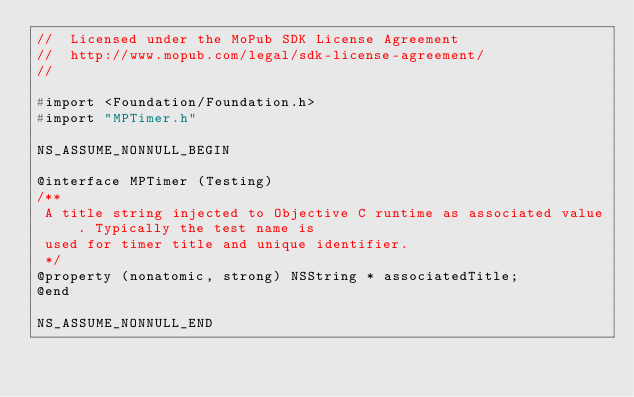Convert code to text. <code><loc_0><loc_0><loc_500><loc_500><_C_>//  Licensed under the MoPub SDK License Agreement
//  http://www.mopub.com/legal/sdk-license-agreement/
//

#import <Foundation/Foundation.h>
#import "MPTimer.h"

NS_ASSUME_NONNULL_BEGIN

@interface MPTimer (Testing)
/**
 A title string injected to Objective C runtime as associated value. Typically the test name is
 used for timer title and unique identifier.
 */
@property (nonatomic, strong) NSString * associatedTitle;
@end

NS_ASSUME_NONNULL_END
</code> 